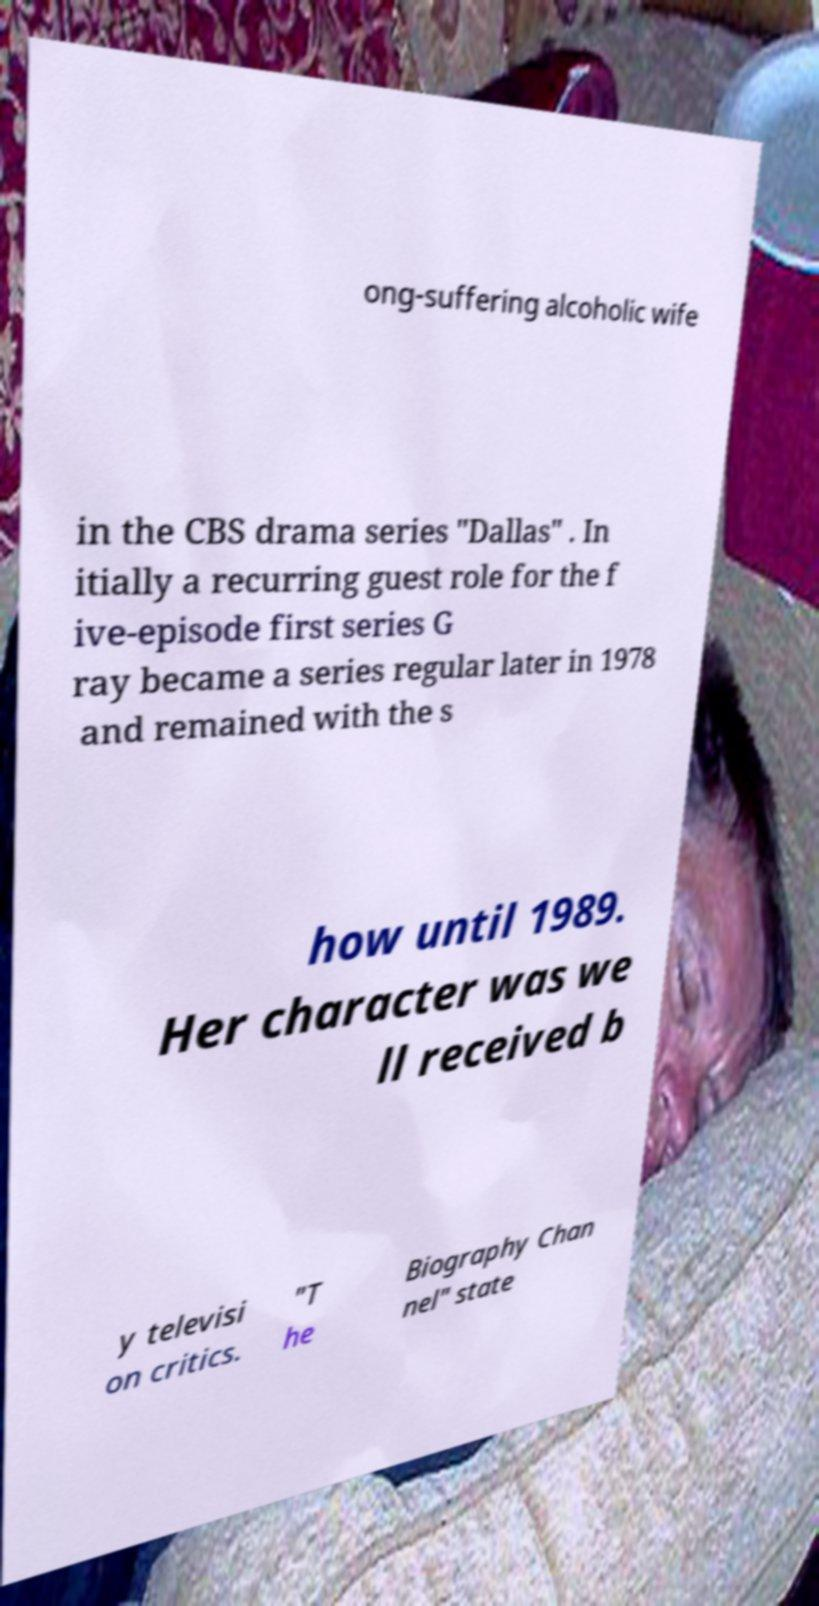I need the written content from this picture converted into text. Can you do that? ong-suffering alcoholic wife in the CBS drama series "Dallas" . In itially a recurring guest role for the f ive-episode first series G ray became a series regular later in 1978 and remained with the s how until 1989. Her character was we ll received b y televisi on critics. "T he Biography Chan nel" state 